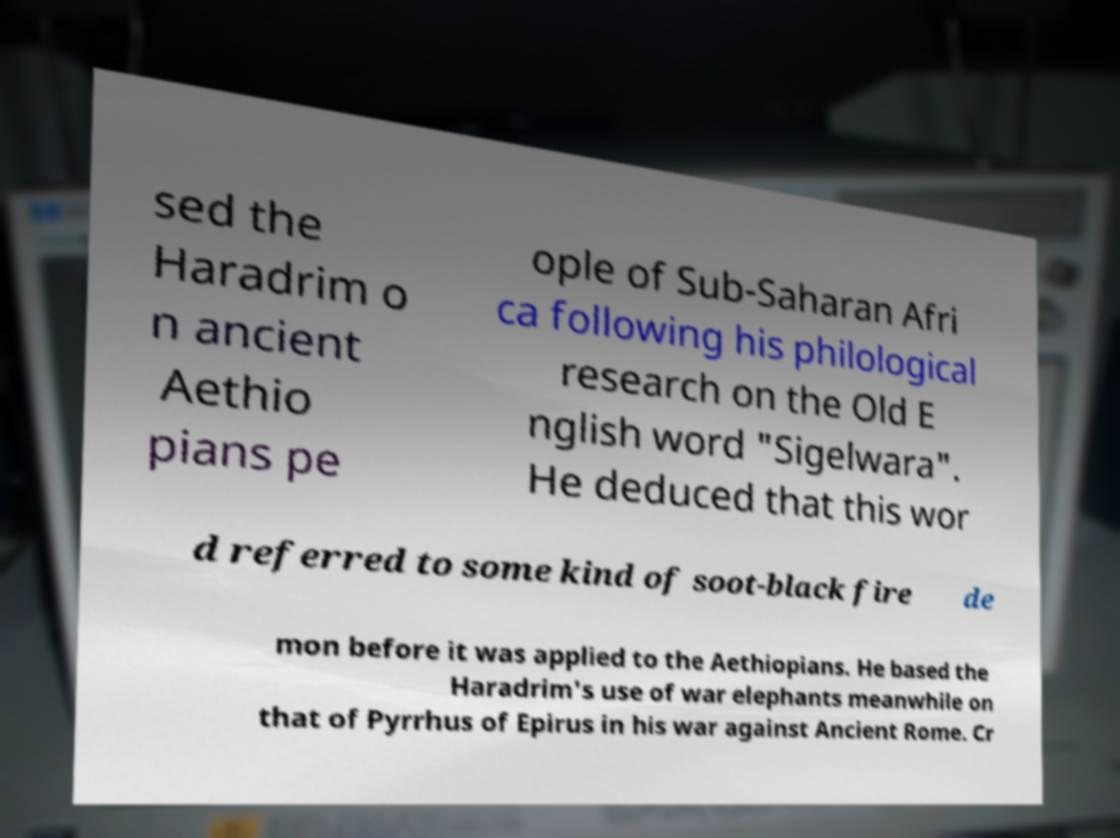What messages or text are displayed in this image? I need them in a readable, typed format. sed the Haradrim o n ancient Aethio pians pe ople of Sub-Saharan Afri ca following his philological research on the Old E nglish word "Sigelwara". He deduced that this wor d referred to some kind of soot-black fire de mon before it was applied to the Aethiopians. He based the Haradrim's use of war elephants meanwhile on that of Pyrrhus of Epirus in his war against Ancient Rome. Cr 